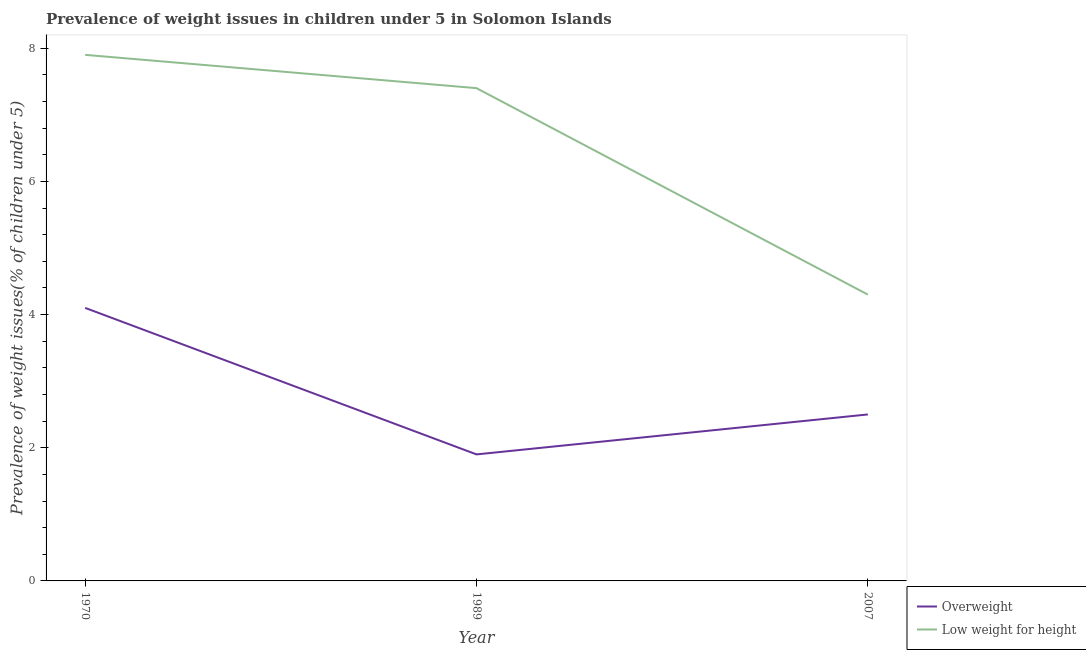How many different coloured lines are there?
Make the answer very short. 2. Does the line corresponding to percentage of underweight children intersect with the line corresponding to percentage of overweight children?
Keep it short and to the point. No. What is the percentage of underweight children in 1970?
Ensure brevity in your answer.  7.9. Across all years, what is the maximum percentage of overweight children?
Your answer should be very brief. 4.1. Across all years, what is the minimum percentage of underweight children?
Ensure brevity in your answer.  4.3. In which year was the percentage of overweight children minimum?
Offer a very short reply. 1989. What is the total percentage of underweight children in the graph?
Keep it short and to the point. 19.6. What is the difference between the percentage of underweight children in 1989 and that in 2007?
Offer a terse response. 3.1. What is the difference between the percentage of overweight children in 1989 and the percentage of underweight children in 2007?
Provide a succinct answer. -2.4. What is the average percentage of underweight children per year?
Your response must be concise. 6.53. In the year 1970, what is the difference between the percentage of underweight children and percentage of overweight children?
Your answer should be very brief. 3.8. What is the ratio of the percentage of underweight children in 1970 to that in 2007?
Your answer should be compact. 1.84. Is the percentage of overweight children in 1989 less than that in 2007?
Your response must be concise. Yes. Is the difference between the percentage of underweight children in 1970 and 1989 greater than the difference between the percentage of overweight children in 1970 and 1989?
Offer a very short reply. No. What is the difference between the highest and the second highest percentage of overweight children?
Provide a short and direct response. 1.6. What is the difference between the highest and the lowest percentage of overweight children?
Your answer should be compact. 2.2. Is the sum of the percentage of overweight children in 1970 and 2007 greater than the maximum percentage of underweight children across all years?
Offer a terse response. No. Does the percentage of underweight children monotonically increase over the years?
Your answer should be very brief. No. How many years are there in the graph?
Give a very brief answer. 3. Are the values on the major ticks of Y-axis written in scientific E-notation?
Offer a terse response. No. Does the graph contain any zero values?
Offer a terse response. No. Does the graph contain grids?
Make the answer very short. No. How many legend labels are there?
Your answer should be compact. 2. What is the title of the graph?
Offer a terse response. Prevalence of weight issues in children under 5 in Solomon Islands. What is the label or title of the Y-axis?
Your answer should be very brief. Prevalence of weight issues(% of children under 5). What is the Prevalence of weight issues(% of children under 5) of Overweight in 1970?
Your answer should be compact. 4.1. What is the Prevalence of weight issues(% of children under 5) of Low weight for height in 1970?
Ensure brevity in your answer.  7.9. What is the Prevalence of weight issues(% of children under 5) in Overweight in 1989?
Offer a very short reply. 1.9. What is the Prevalence of weight issues(% of children under 5) of Low weight for height in 1989?
Your answer should be compact. 7.4. What is the Prevalence of weight issues(% of children under 5) in Low weight for height in 2007?
Provide a short and direct response. 4.3. Across all years, what is the maximum Prevalence of weight issues(% of children under 5) in Overweight?
Offer a terse response. 4.1. Across all years, what is the maximum Prevalence of weight issues(% of children under 5) of Low weight for height?
Ensure brevity in your answer.  7.9. Across all years, what is the minimum Prevalence of weight issues(% of children under 5) in Overweight?
Provide a short and direct response. 1.9. Across all years, what is the minimum Prevalence of weight issues(% of children under 5) in Low weight for height?
Offer a terse response. 4.3. What is the total Prevalence of weight issues(% of children under 5) of Overweight in the graph?
Make the answer very short. 8.5. What is the total Prevalence of weight issues(% of children under 5) in Low weight for height in the graph?
Your response must be concise. 19.6. What is the difference between the Prevalence of weight issues(% of children under 5) of Overweight in 1970 and that in 1989?
Offer a very short reply. 2.2. What is the difference between the Prevalence of weight issues(% of children under 5) of Low weight for height in 1970 and that in 2007?
Your answer should be very brief. 3.6. What is the difference between the Prevalence of weight issues(% of children under 5) of Overweight in 1989 and that in 2007?
Your response must be concise. -0.6. What is the difference between the Prevalence of weight issues(% of children under 5) of Overweight in 1970 and the Prevalence of weight issues(% of children under 5) of Low weight for height in 1989?
Offer a terse response. -3.3. What is the difference between the Prevalence of weight issues(% of children under 5) in Overweight in 1989 and the Prevalence of weight issues(% of children under 5) in Low weight for height in 2007?
Offer a terse response. -2.4. What is the average Prevalence of weight issues(% of children under 5) in Overweight per year?
Your response must be concise. 2.83. What is the average Prevalence of weight issues(% of children under 5) of Low weight for height per year?
Your answer should be very brief. 6.53. In the year 1989, what is the difference between the Prevalence of weight issues(% of children under 5) of Overweight and Prevalence of weight issues(% of children under 5) of Low weight for height?
Provide a short and direct response. -5.5. What is the ratio of the Prevalence of weight issues(% of children under 5) in Overweight in 1970 to that in 1989?
Provide a succinct answer. 2.16. What is the ratio of the Prevalence of weight issues(% of children under 5) in Low weight for height in 1970 to that in 1989?
Provide a short and direct response. 1.07. What is the ratio of the Prevalence of weight issues(% of children under 5) in Overweight in 1970 to that in 2007?
Your answer should be compact. 1.64. What is the ratio of the Prevalence of weight issues(% of children under 5) of Low weight for height in 1970 to that in 2007?
Make the answer very short. 1.84. What is the ratio of the Prevalence of weight issues(% of children under 5) of Overweight in 1989 to that in 2007?
Ensure brevity in your answer.  0.76. What is the ratio of the Prevalence of weight issues(% of children under 5) in Low weight for height in 1989 to that in 2007?
Your answer should be compact. 1.72. What is the difference between the highest and the second highest Prevalence of weight issues(% of children under 5) of Low weight for height?
Your answer should be very brief. 0.5. 